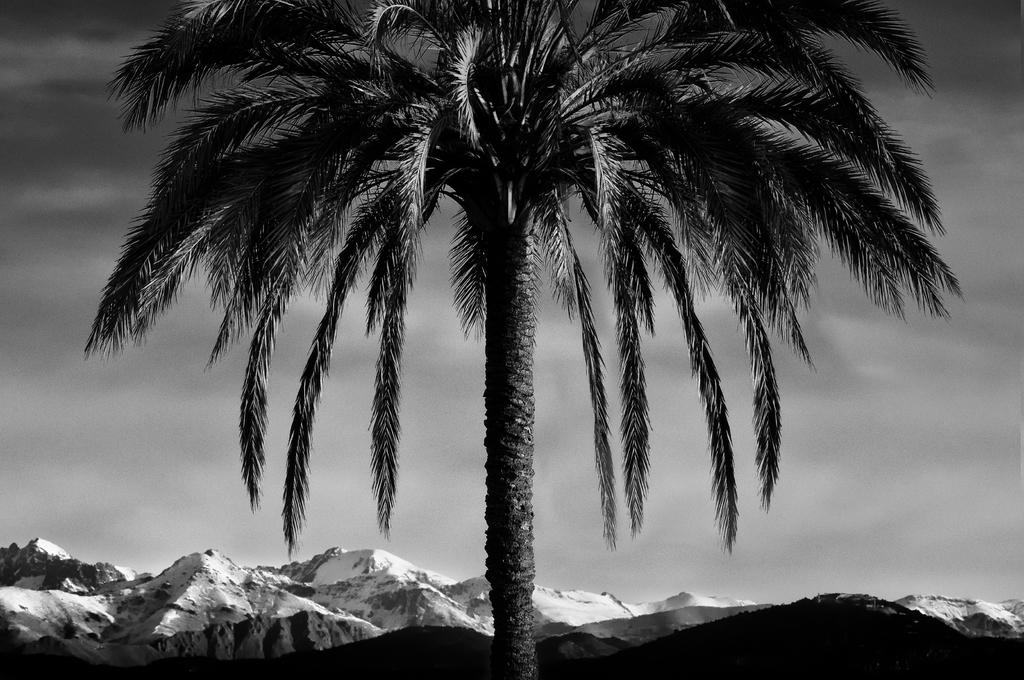What is the color scheme of the image? The image is black and white. What is the main subject in the image? There is a tree in the middle of the image. What can be seen behind the tree? There are hills behind the tree. What is visible in the background of the image? The sky is visible in the background of the image. What type of test can be seen being conducted on the tree in the image? There is no test being conducted on the tree in the image; it is a static image of a tree with hills and sky in the background. 